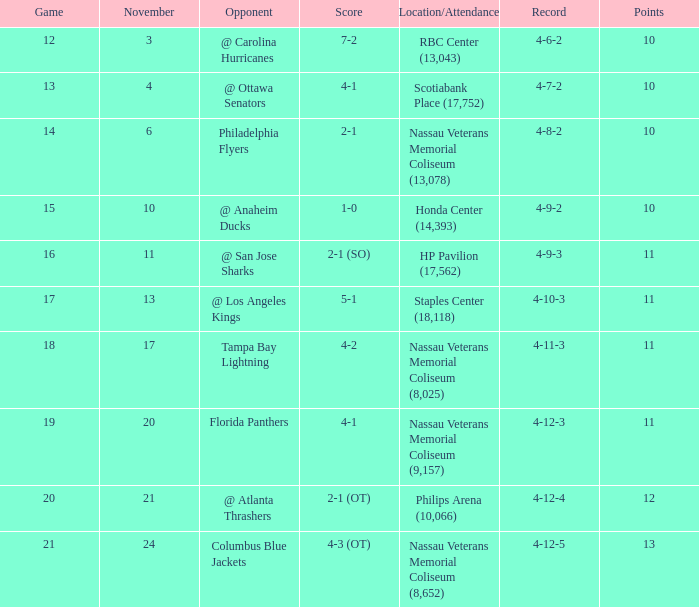What is the least entry for game if the score is 1-0? 15.0. 